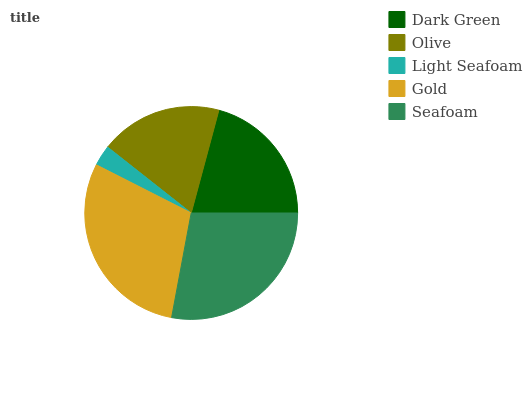Is Light Seafoam the minimum?
Answer yes or no. Yes. Is Gold the maximum?
Answer yes or no. Yes. Is Olive the minimum?
Answer yes or no. No. Is Olive the maximum?
Answer yes or no. No. Is Dark Green greater than Olive?
Answer yes or no. Yes. Is Olive less than Dark Green?
Answer yes or no. Yes. Is Olive greater than Dark Green?
Answer yes or no. No. Is Dark Green less than Olive?
Answer yes or no. No. Is Dark Green the high median?
Answer yes or no. Yes. Is Dark Green the low median?
Answer yes or no. Yes. Is Light Seafoam the high median?
Answer yes or no. No. Is Gold the low median?
Answer yes or no. No. 